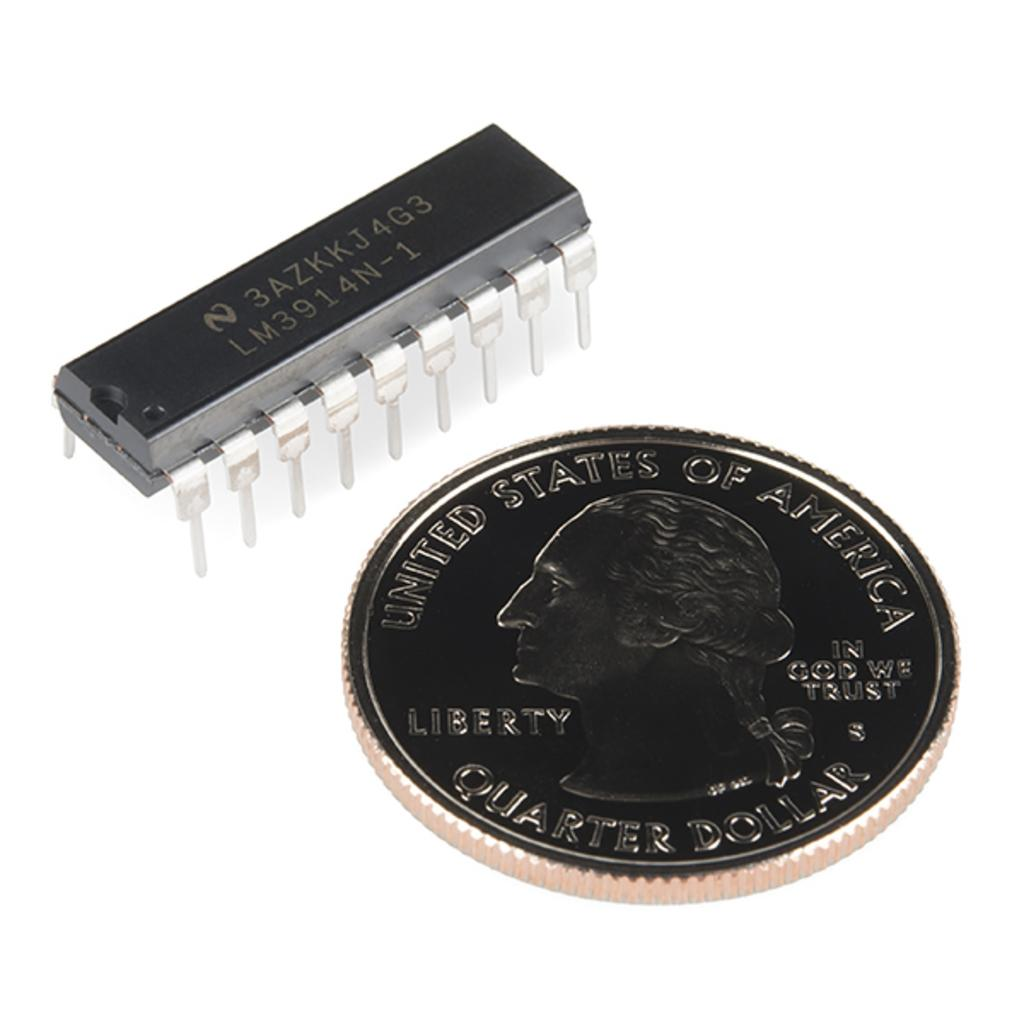<image>
Write a terse but informative summary of the picture. A quarter dollar and a small black device sit on a light table. 